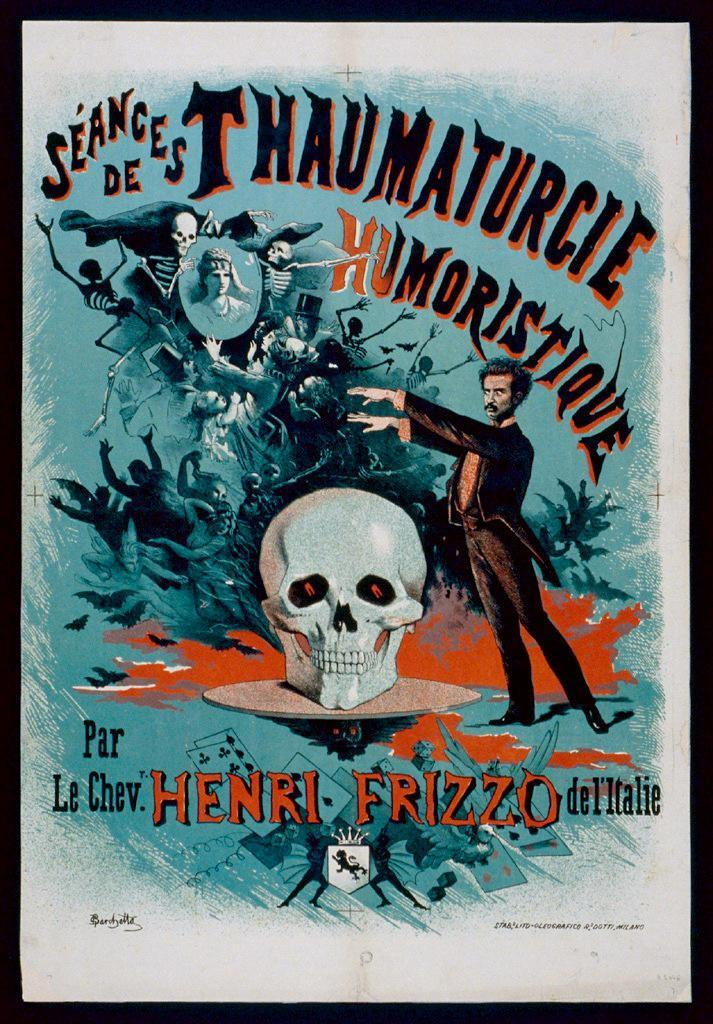<image>
Summarize the visual content of the image. An old book by Henri Frizzo about Seances. 